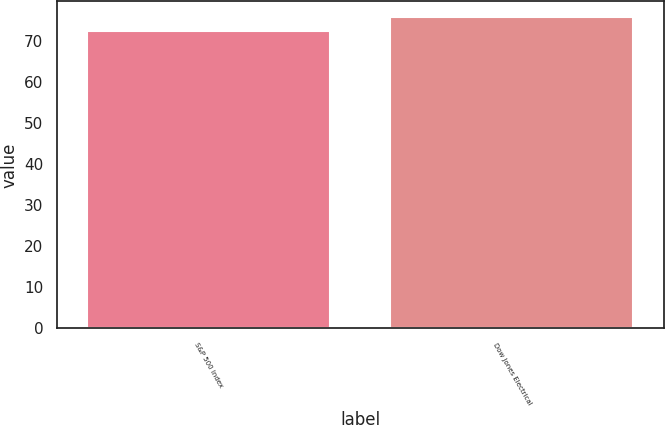Convert chart. <chart><loc_0><loc_0><loc_500><loc_500><bar_chart><fcel>S&P 500 Index<fcel>Dow Jones Electrical<nl><fcel>72.29<fcel>75.74<nl></chart> 